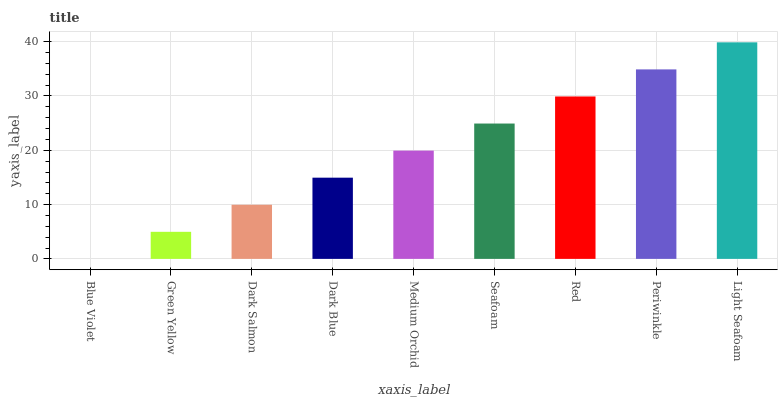Is Blue Violet the minimum?
Answer yes or no. Yes. Is Light Seafoam the maximum?
Answer yes or no. Yes. Is Green Yellow the minimum?
Answer yes or no. No. Is Green Yellow the maximum?
Answer yes or no. No. Is Green Yellow greater than Blue Violet?
Answer yes or no. Yes. Is Blue Violet less than Green Yellow?
Answer yes or no. Yes. Is Blue Violet greater than Green Yellow?
Answer yes or no. No. Is Green Yellow less than Blue Violet?
Answer yes or no. No. Is Medium Orchid the high median?
Answer yes or no. Yes. Is Medium Orchid the low median?
Answer yes or no. Yes. Is Red the high median?
Answer yes or no. No. Is Light Seafoam the low median?
Answer yes or no. No. 